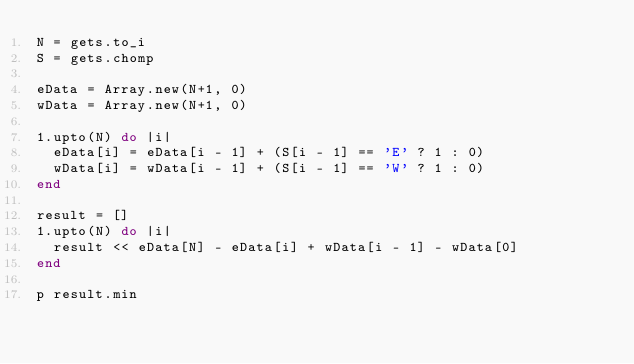Convert code to text. <code><loc_0><loc_0><loc_500><loc_500><_Ruby_>N = gets.to_i
S = gets.chomp

eData = Array.new(N+1, 0)
wData = Array.new(N+1, 0)

1.upto(N) do |i|
  eData[i] = eData[i - 1] + (S[i - 1] == 'E' ? 1 : 0)
  wData[i] = wData[i - 1] + (S[i - 1] == 'W' ? 1 : 0)
end

result = []
1.upto(N) do |i|
  result << eData[N] - eData[i] + wData[i - 1] - wData[0]
end

p result.min</code> 